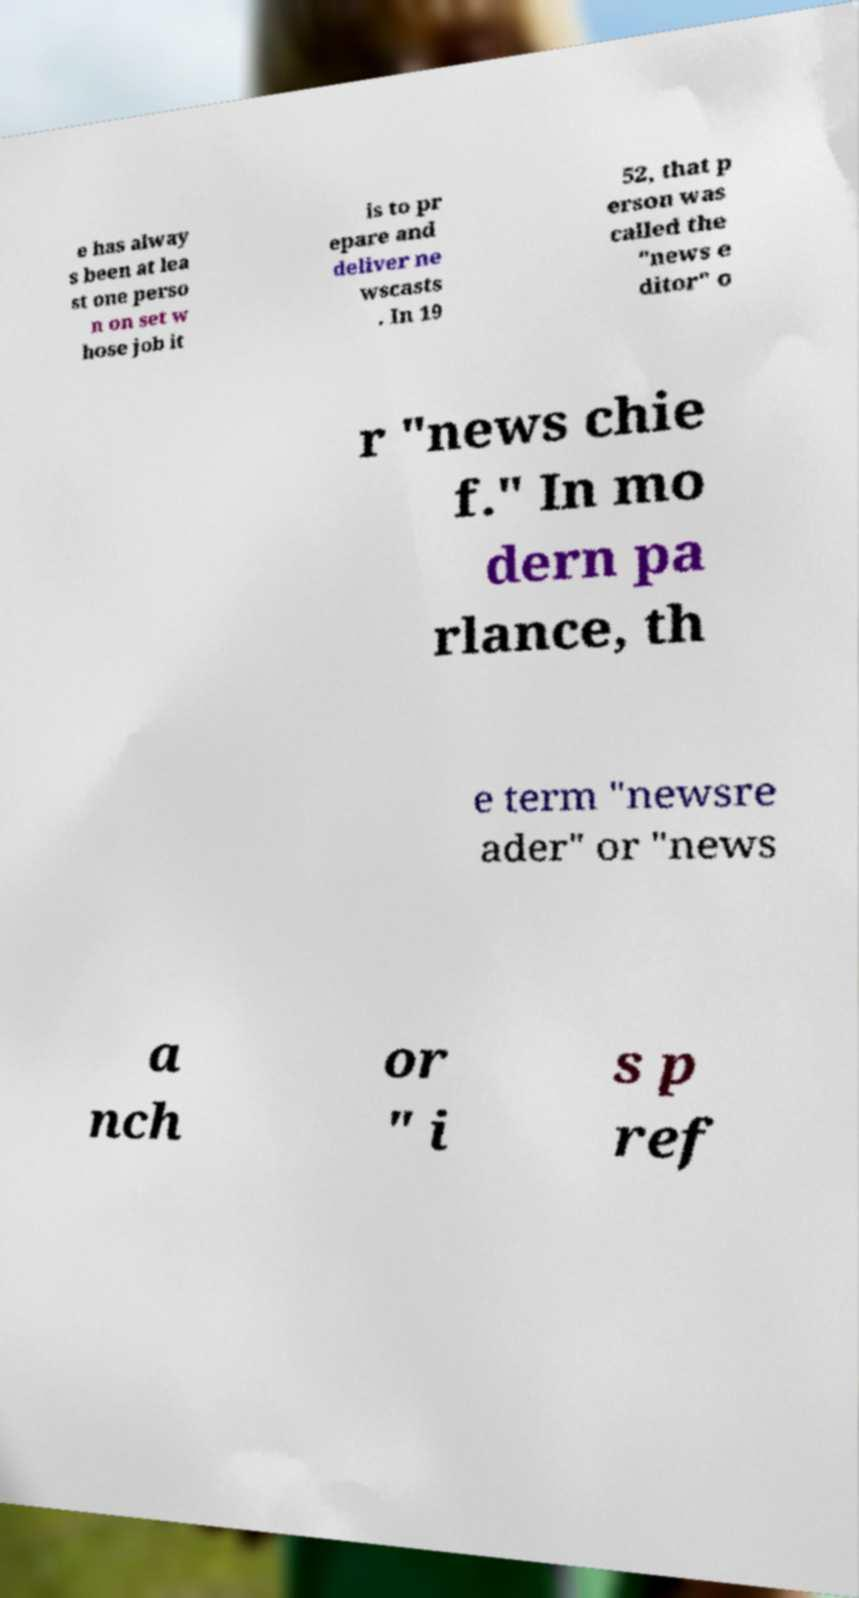What messages or text are displayed in this image? I need them in a readable, typed format. e has alway s been at lea st one perso n on set w hose job it is to pr epare and deliver ne wscasts . In 19 52, that p erson was called the "news e ditor" o r "news chie f." In mo dern pa rlance, th e term "newsre ader" or "news a nch or " i s p ref 